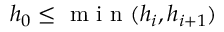Convert formula to latex. <formula><loc_0><loc_0><loc_500><loc_500>h _ { 0 } \leq \min ( h _ { i } , h _ { i + 1 } )</formula> 